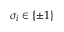<formula> <loc_0><loc_0><loc_500><loc_500>\sigma _ { i } \in \{ \pm 1 \}</formula> 